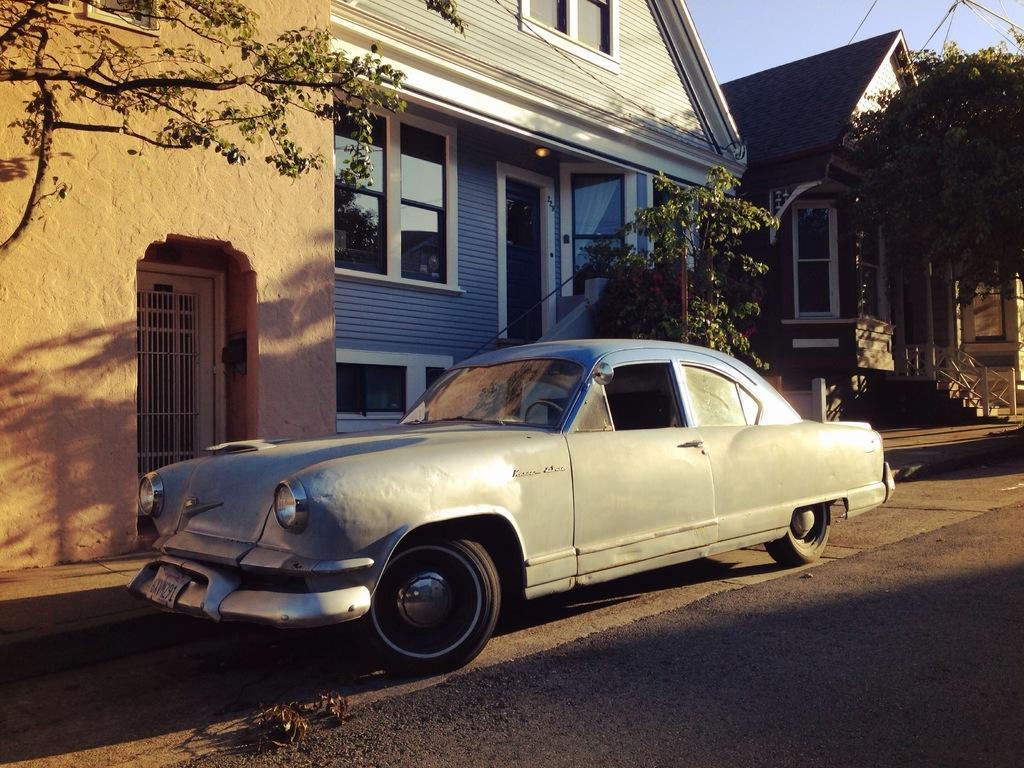Describe this image in one or two sentences. In the image there are two houses and there is a wall on the left side and in front of the wall there is a car parked on the road, there are trees in front of the houses. 